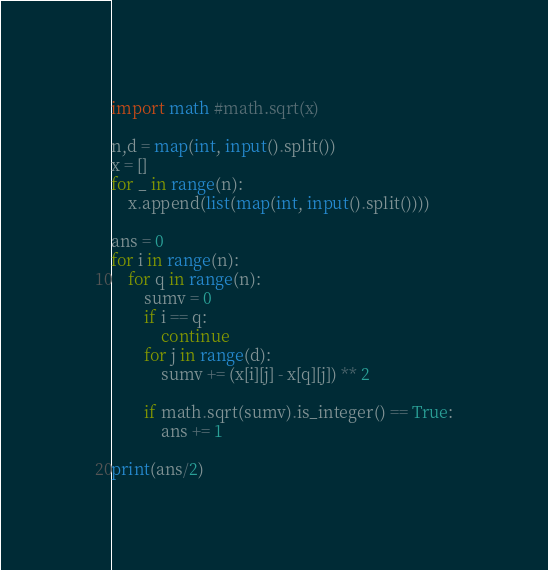<code> <loc_0><loc_0><loc_500><loc_500><_Python_>import math #math.sqrt(x)

n,d = map(int, input().split())
x = []
for _ in range(n):
    x.append(list(map(int, input().split())))

ans = 0
for i in range(n):
    for q in range(n):
        sumv = 0
        if i == q:
            continue
        for j in range(d):
            sumv += (x[i][j] - x[q][j]) ** 2

        if math.sqrt(sumv).is_integer() == True:
            ans += 1

print(ans/2)</code> 